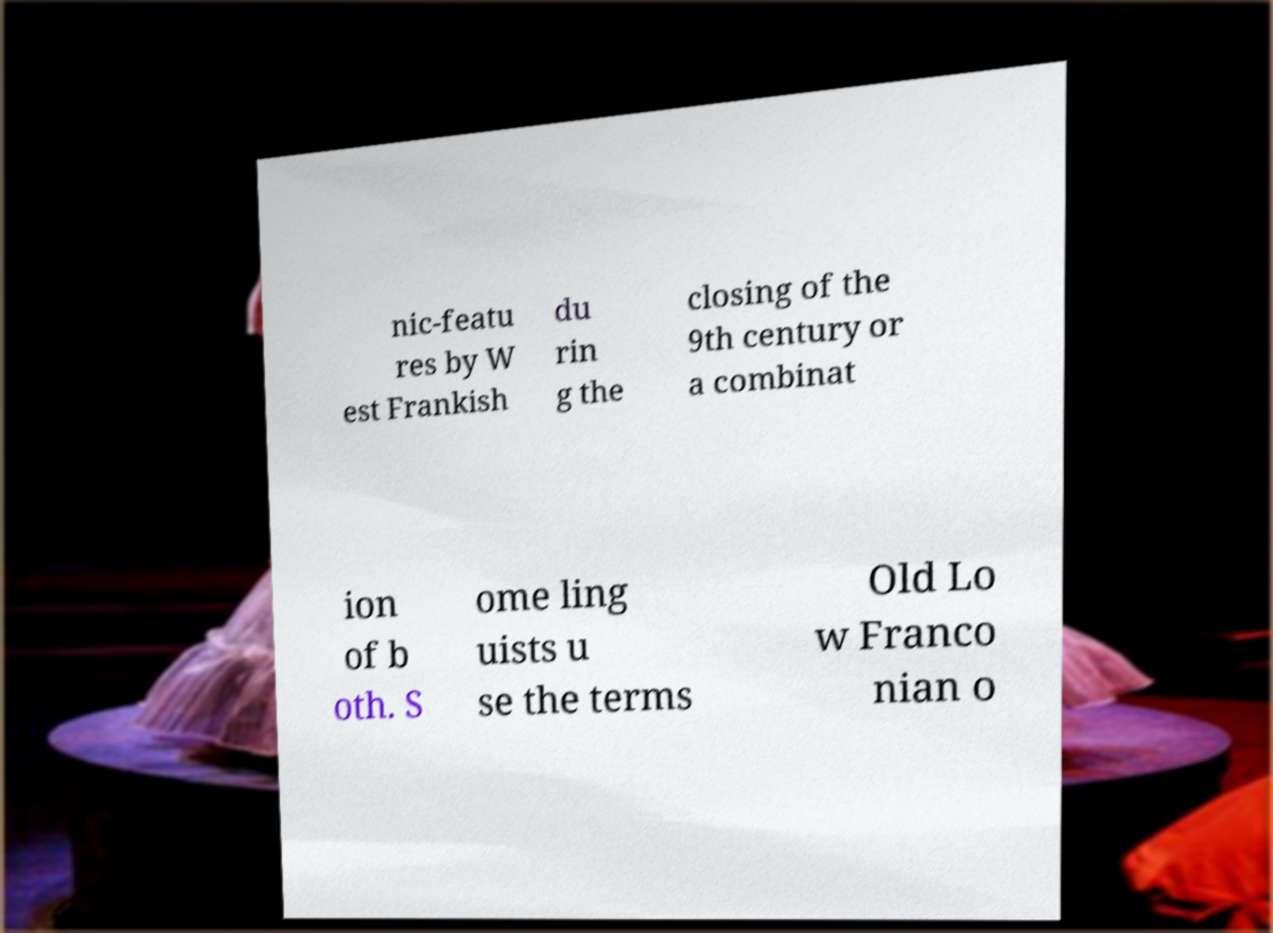Can you read and provide the text displayed in the image?This photo seems to have some interesting text. Can you extract and type it out for me? nic-featu res by W est Frankish du rin g the closing of the 9th century or a combinat ion of b oth. S ome ling uists u se the terms Old Lo w Franco nian o 